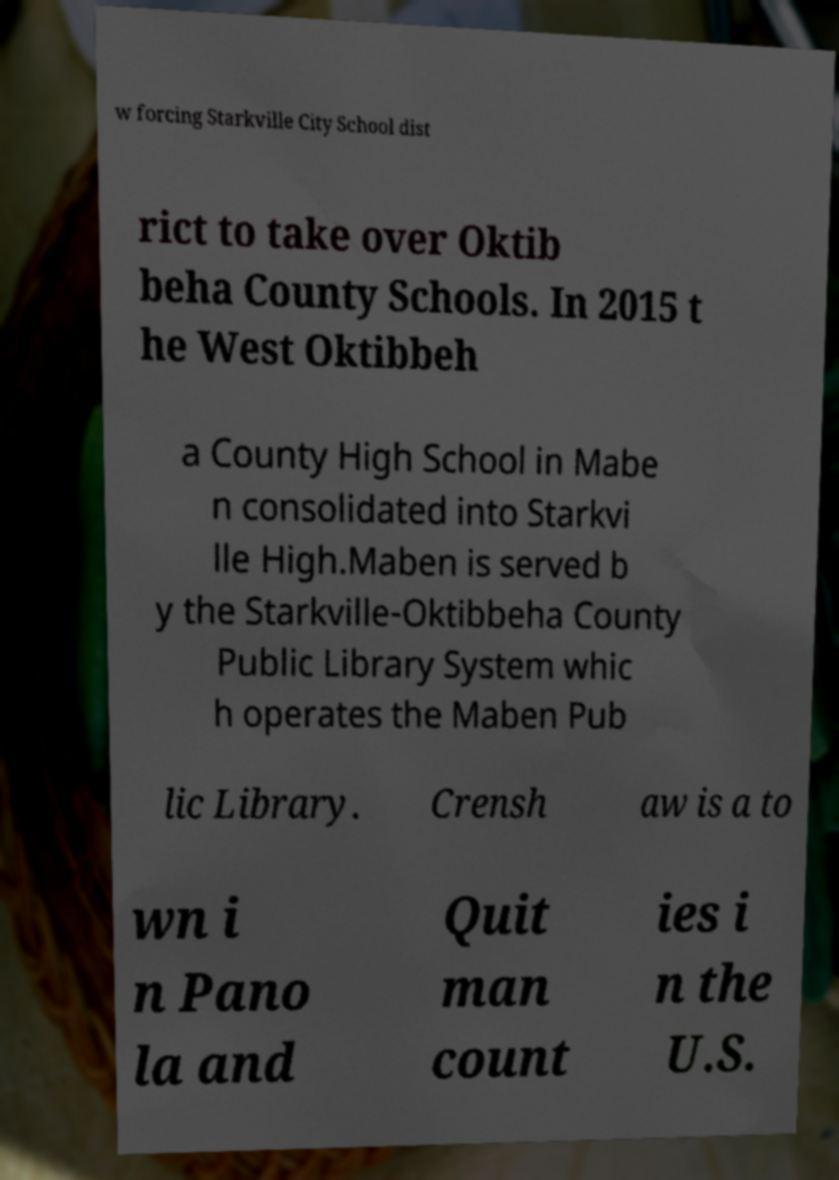Please identify and transcribe the text found in this image. w forcing Starkville City School dist rict to take over Oktib beha County Schools. In 2015 t he West Oktibbeh a County High School in Mabe n consolidated into Starkvi lle High.Maben is served b y the Starkville-Oktibbeha County Public Library System whic h operates the Maben Pub lic Library. Crensh aw is a to wn i n Pano la and Quit man count ies i n the U.S. 